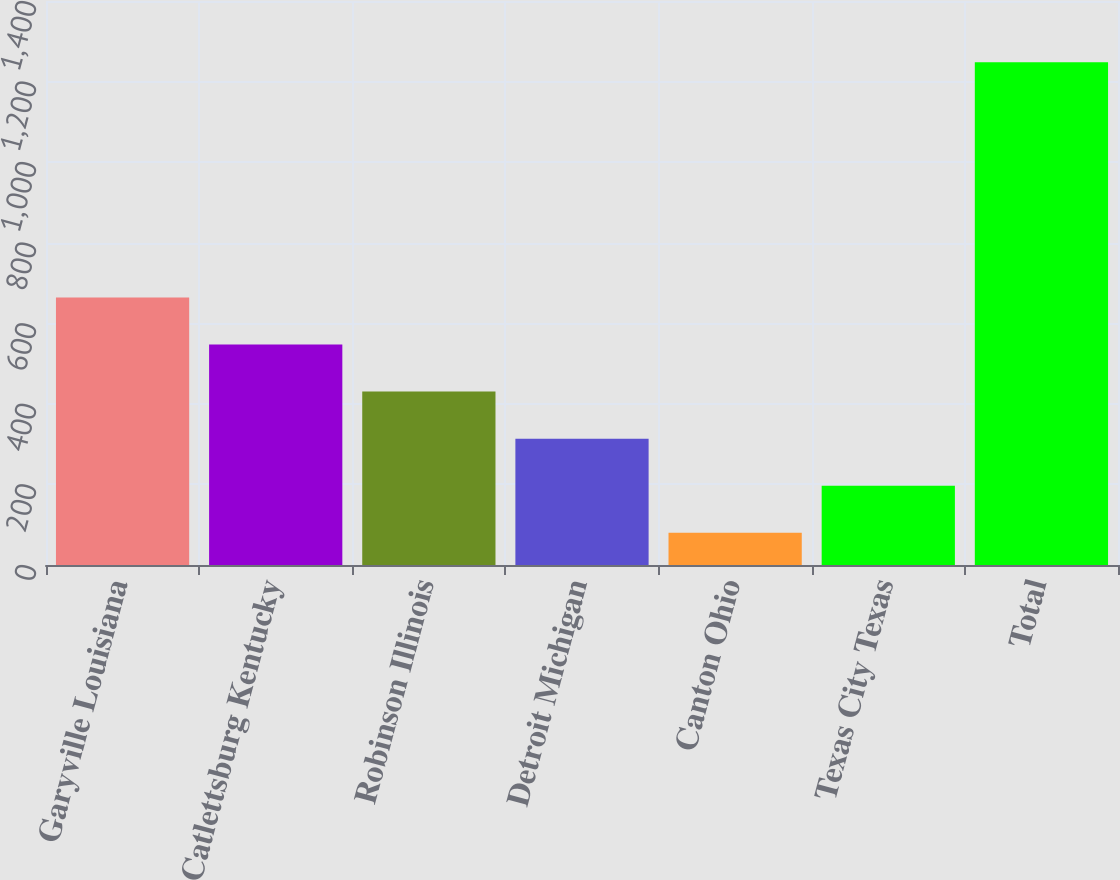Convert chart. <chart><loc_0><loc_0><loc_500><loc_500><bar_chart><fcel>Garyville Louisiana<fcel>Catlettsburg Kentucky<fcel>Robinson Illinois<fcel>Detroit Michigan<fcel>Canton Ohio<fcel>Texas City Texas<fcel>Total<nl><fcel>664<fcel>547.2<fcel>430.4<fcel>313.6<fcel>80<fcel>196.8<fcel>1248<nl></chart> 